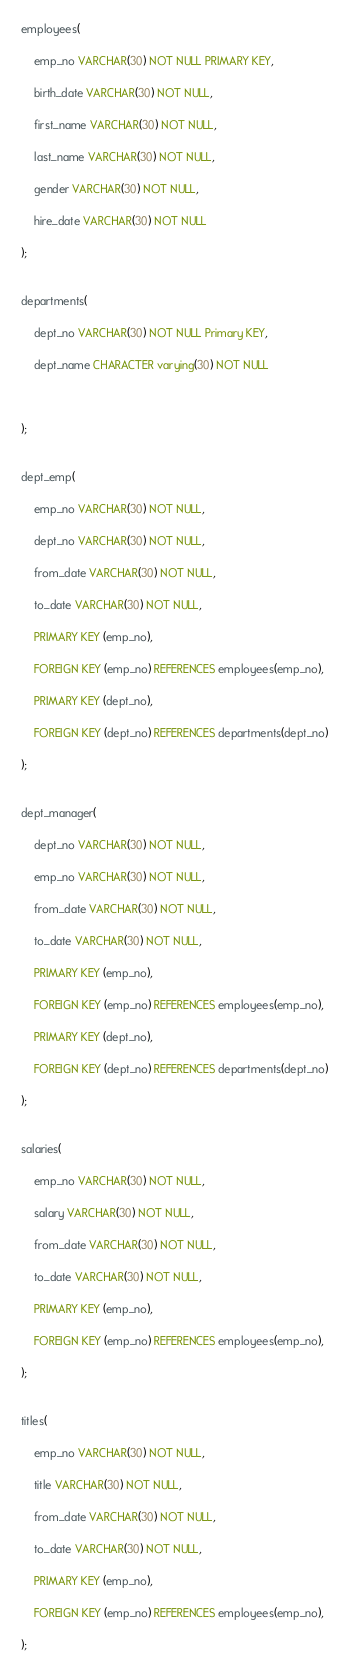Convert code to text. <code><loc_0><loc_0><loc_500><loc_500><_SQL_>employees(

	emp_no VARCHAR(30) NOT NULL PRIMARY KEY,

	birth_date VARCHAR(30) NOT NULL,

	first_name VARCHAR(30) NOT NULL,

	last_name VARCHAR(30) NOT NULL,

	gender VARCHAR(30) NOT NULL,

	hire_date VARCHAR(30) NOT NULL

);


departments(

	dept_no VARCHAR(30) NOT NULL Primary KEY,

	dept_name CHARACTER varying(30) NOT NULL

	

);


dept_emp(

	emp_no VARCHAR(30) NOT NULL,

	dept_no VARCHAR(30) NOT NULL,

	from_date VARCHAR(30) NOT NULL,

	to_date VARCHAR(30) NOT NULL,

	PRIMARY KEY (emp_no),

	FOREIGN KEY (emp_no) REFERENCES employees(emp_no),

	PRIMARY KEY (dept_no),

	FOREIGN KEY (dept_no) REFERENCES departments(dept_no)

);


dept_manager(

	dept_no VARCHAR(30) NOT NULL,

	emp_no VARCHAR(30) NOT NULL,

	from_date VARCHAR(30) NOT NULL,

	to_date VARCHAR(30) NOT NULL,

	PRIMARY KEY (emp_no),

	FOREIGN KEY (emp_no) REFERENCES employees(emp_no),

	PRIMARY KEY (dept_no),

	FOREIGN KEY (dept_no) REFERENCES departments(dept_no)

);


salaries(

	emp_no VARCHAR(30) NOT NULL,

	salary VARCHAR(30) NOT NULL,

	from_date VARCHAR(30) NOT NULL,

	to_date VARCHAR(30) NOT NULL,

	PRIMARY KEY (emp_no),

	FOREIGN KEY (emp_no) REFERENCES employees(emp_no),

);


titles(

	emp_no VARCHAR(30) NOT NULL,

	title VARCHAR(30) NOT NULL,

	from_date VARCHAR(30) NOT NULL,

	to_date VARCHAR(30) NOT NULL,

	PRIMARY KEY (emp_no),

	FOREIGN KEY (emp_no) REFERENCES employees(emp_no),

);</code> 